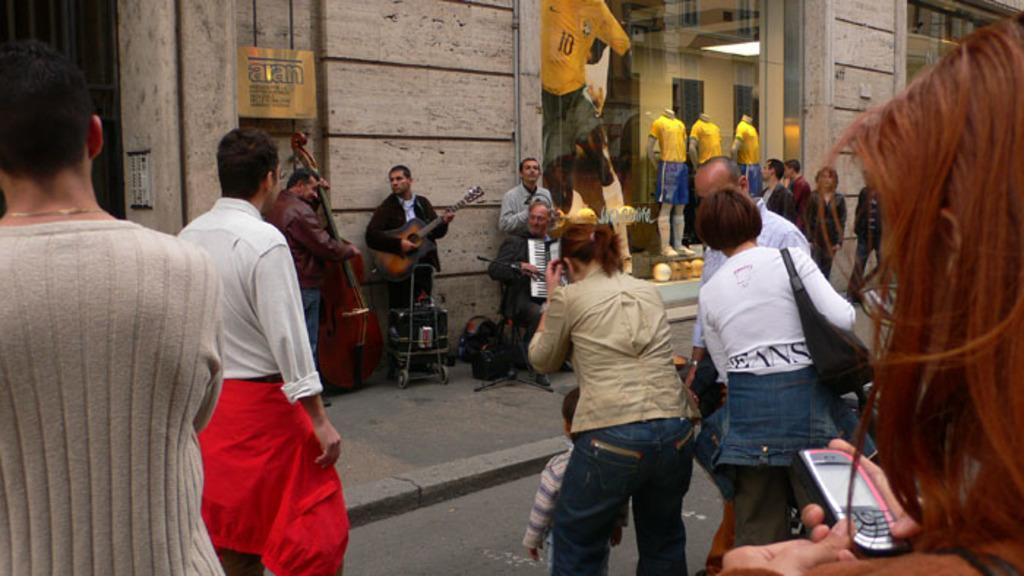How would you summarize this image in a sentence or two? In this image we can see a group of people playing/holding musical instruments. And we can see the audience. And we can see the glass window. And we can see the road and the wall. 